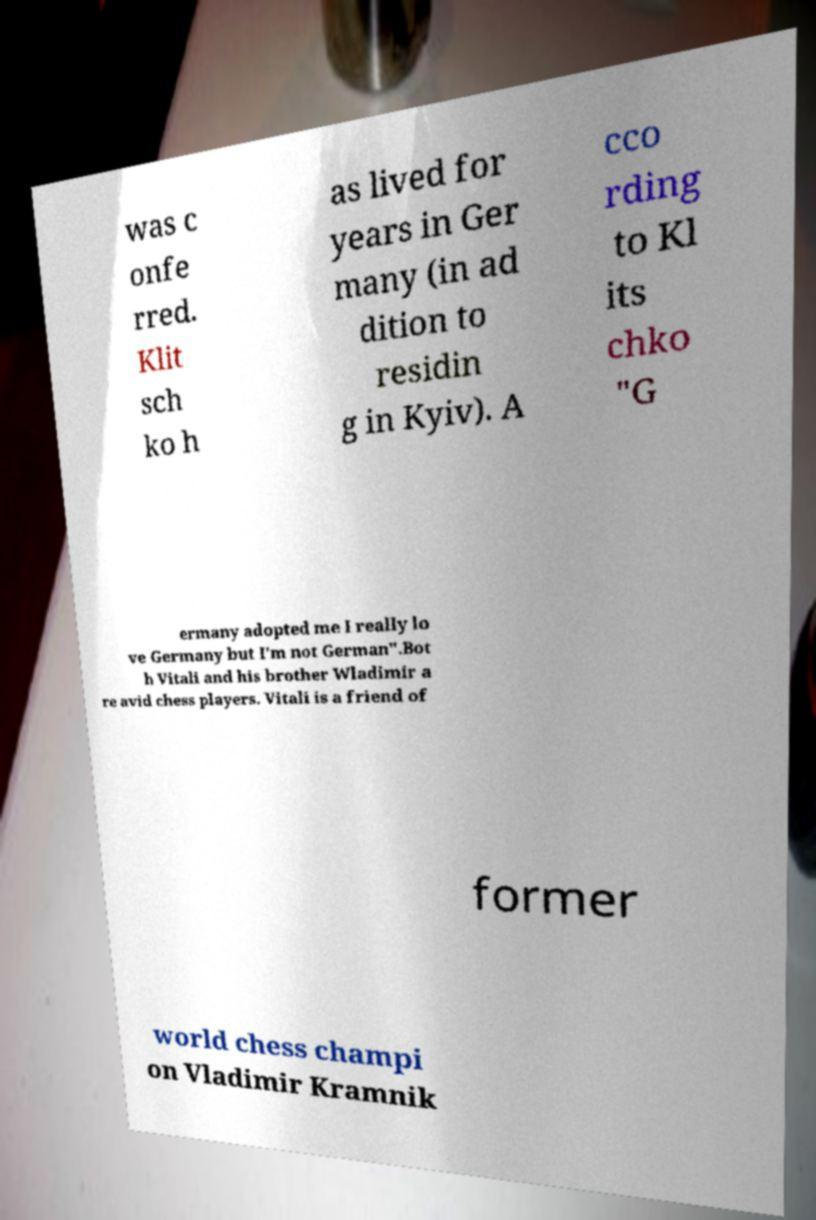I need the written content from this picture converted into text. Can you do that? was c onfe rred. Klit sch ko h as lived for years in Ger many (in ad dition to residin g in Kyiv). A cco rding to Kl its chko "G ermany adopted me I really lo ve Germany but I'm not German".Bot h Vitali and his brother Wladimir a re avid chess players. Vitali is a friend of former world chess champi on Vladimir Kramnik 